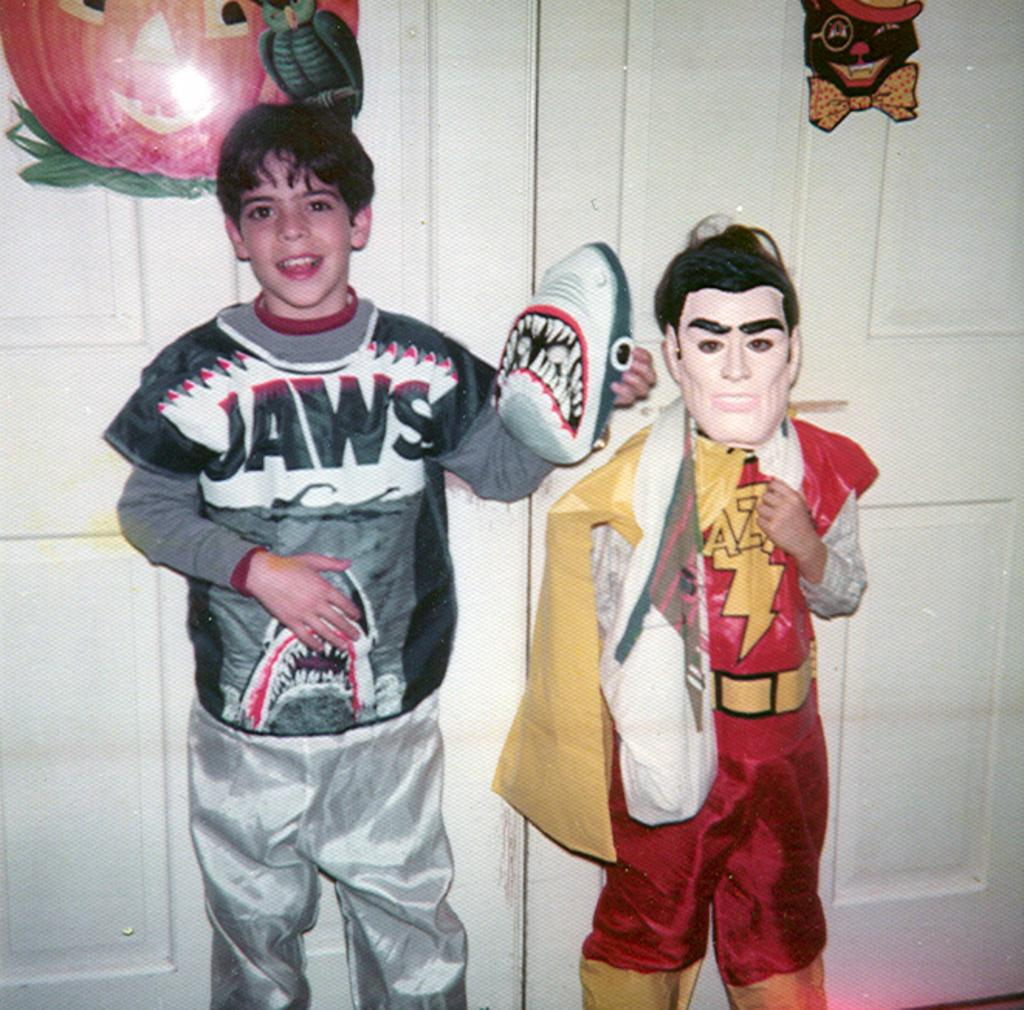<image>
Write a terse but informative summary of the picture. Two children in costume of Jaws and a super hero. 